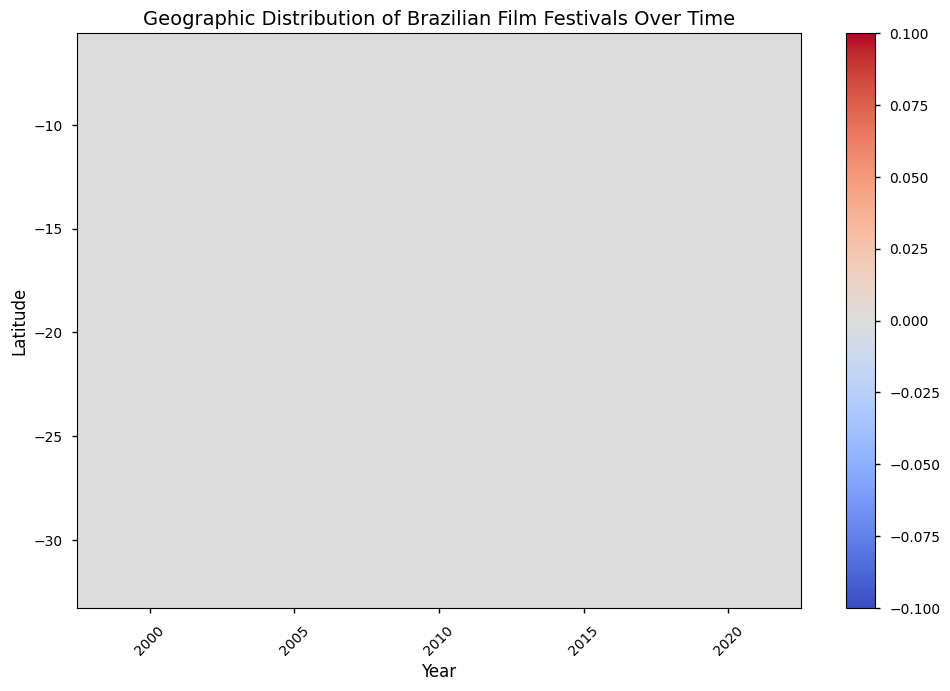What's the general trend in the number of film festivals in São Paulo (-23.5505, -46.6333) over the years? As you move along the years in the heatmap, observe the color intensity corresponding to São Paulo. The colors become progressively deeper, indicating an increasing number of festivals. Specifically, the count rises from 3 in 2000 to 10 in 2020.
Answer: The number of festivals increases Which city had the highest increase in the number of film festivals from 2005 to 2020? Compare the color intensities for each city between these years. São Paulo (-23.5505, -46.6333) shows a significant increase, with the festival count rising from 5 in 2005 to 10 in 2020, the highest among all cities.
Answer: São Paulo What is the total number of film festivals in Rio de Janeiro (-22.9068, -43.1729) from 2000 to 2020? For Rio de Janeiro, sum the numbers from the years 2000 (2), 2005 (3), 2010 (4), 2015 (5), and 2020 (6). The sum of these values is 2 + 3 + 4 + 5 + 6 = 20.
Answer: 20 Which latitude had the most consistent increase in the number of film festivals over the years? Examine the rows in the heatmap and see which latitude has a steady color gradient. São Paulo (-23.5505) shows a consistent increase in festival numbers for each successive year.
Answer: -23.5505 Among the locations listed, was there any new city that introduced film festivals in 2015? Check the 2015 column in the heatmap for any new colors appearing at a latitude that previously had a value of 0. Salvador (-12.9714) only shows data starting in 2015.
Answer: Salvador (-12.9714) Which year has the highest number of total film festivals across all cities? Sum the festival counts for all cities for each year. The sum for 2020 is the highest: 10 (São Paulo) + 6 (Rio de Janeiro) + 5 (Porto Alegre) + 4 (Brasília) + 3 (Belo Horizonte) + 2 (Salvador) + 1 (Recife), making a total of 31.
Answer: 2020 How does the growth of film festivals in Brasília (-15.7801, -47.9292) compare to that in Porto Alegre (-30.0346, -51.2177) between 2005 and 2020? In 2005, Brasília has 1 festival, increasing to 4 by 2020. Porto Alegre starts at 2 in 2005 and rises to 5 by 2020. Porto Alegre has a higher increase in actual count (3 festivals) compared to Brasília (3 festivals as well but started later).
Answer: Porto Alegre's growth is higher What's the average number of film festivals held in Belo Horizonte (-19.9191, -43.9386) from 2010 onwards? Belo Horizonte has festival counts for 2010 (1), 2015 (2), and 2020 (3). The average is calculated as (1 + 2 + 3) / 3 = 2.
Answer: 2 